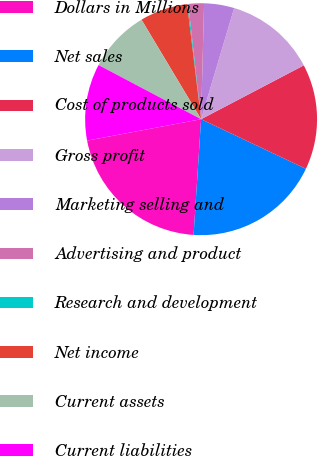<chart> <loc_0><loc_0><loc_500><loc_500><pie_chart><fcel>Dollars in Millions<fcel>Net sales<fcel>Cost of products sold<fcel>Gross profit<fcel>Marketing selling and<fcel>Advertising and product<fcel>Research and development<fcel>Net income<fcel>Current assets<fcel>Current liabilities<nl><fcel>21.01%<fcel>18.99%<fcel>14.72%<fcel>12.71%<fcel>4.19%<fcel>2.18%<fcel>0.16%<fcel>6.66%<fcel>8.68%<fcel>10.69%<nl></chart> 